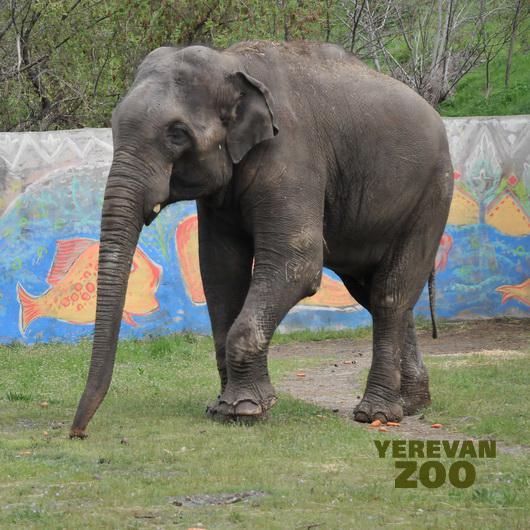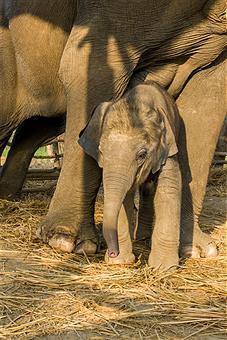The first image is the image on the left, the second image is the image on the right. Examine the images to the left and right. Is the description "An image shows one small elephant with its head poking under the legs of an adult elephant with a curled trunk." accurate? Answer yes or no. No. The first image is the image on the left, the second image is the image on the right. Given the left and right images, does the statement "An elephant's trunk is curved up." hold true? Answer yes or no. No. 